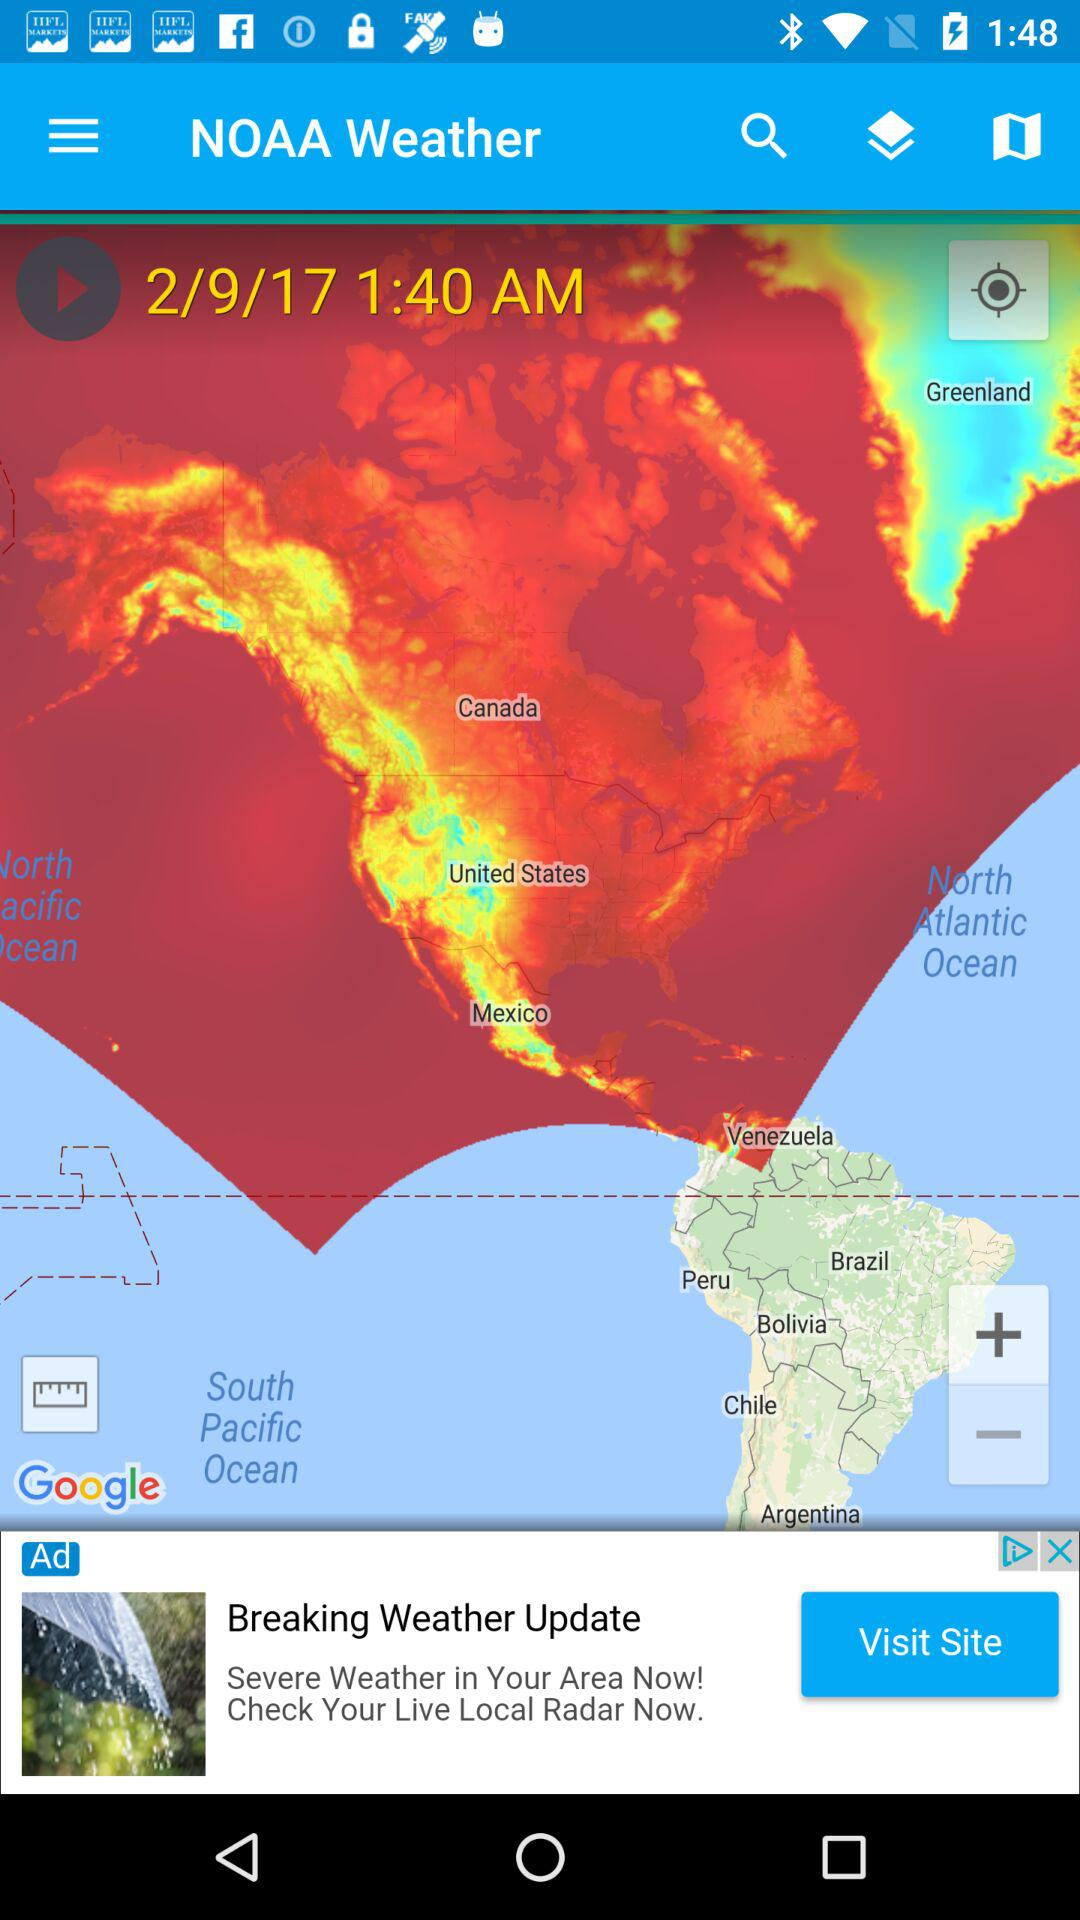What was the date and time on the map? The date and time on the map were February 9, 2017 and 1:40 a.m., respectively. 